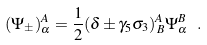Convert formula to latex. <formula><loc_0><loc_0><loc_500><loc_500>( \Psi _ { \pm } ) ^ { A } _ { \alpha } = \frac { 1 } { 2 } ( \delta \pm \gamma _ { 5 } \sigma _ { 3 } ) ^ { A } _ { \, B } \Psi _ { \alpha } ^ { B } \ .</formula> 